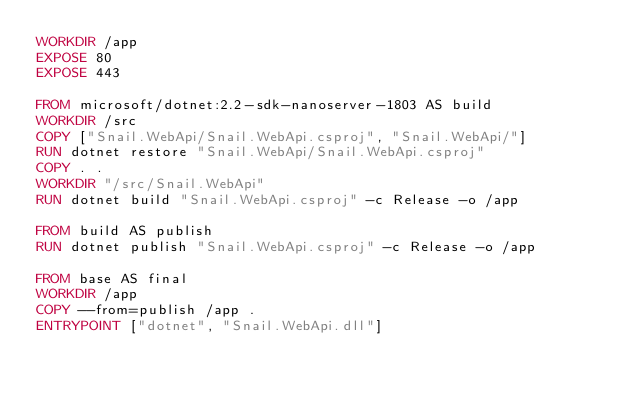Convert code to text. <code><loc_0><loc_0><loc_500><loc_500><_Dockerfile_>WORKDIR /app
EXPOSE 80
EXPOSE 443

FROM microsoft/dotnet:2.2-sdk-nanoserver-1803 AS build
WORKDIR /src
COPY ["Snail.WebApi/Snail.WebApi.csproj", "Snail.WebApi/"]
RUN dotnet restore "Snail.WebApi/Snail.WebApi.csproj"
COPY . .
WORKDIR "/src/Snail.WebApi"
RUN dotnet build "Snail.WebApi.csproj" -c Release -o /app

FROM build AS publish
RUN dotnet publish "Snail.WebApi.csproj" -c Release -o /app

FROM base AS final
WORKDIR /app
COPY --from=publish /app .
ENTRYPOINT ["dotnet", "Snail.WebApi.dll"]</code> 